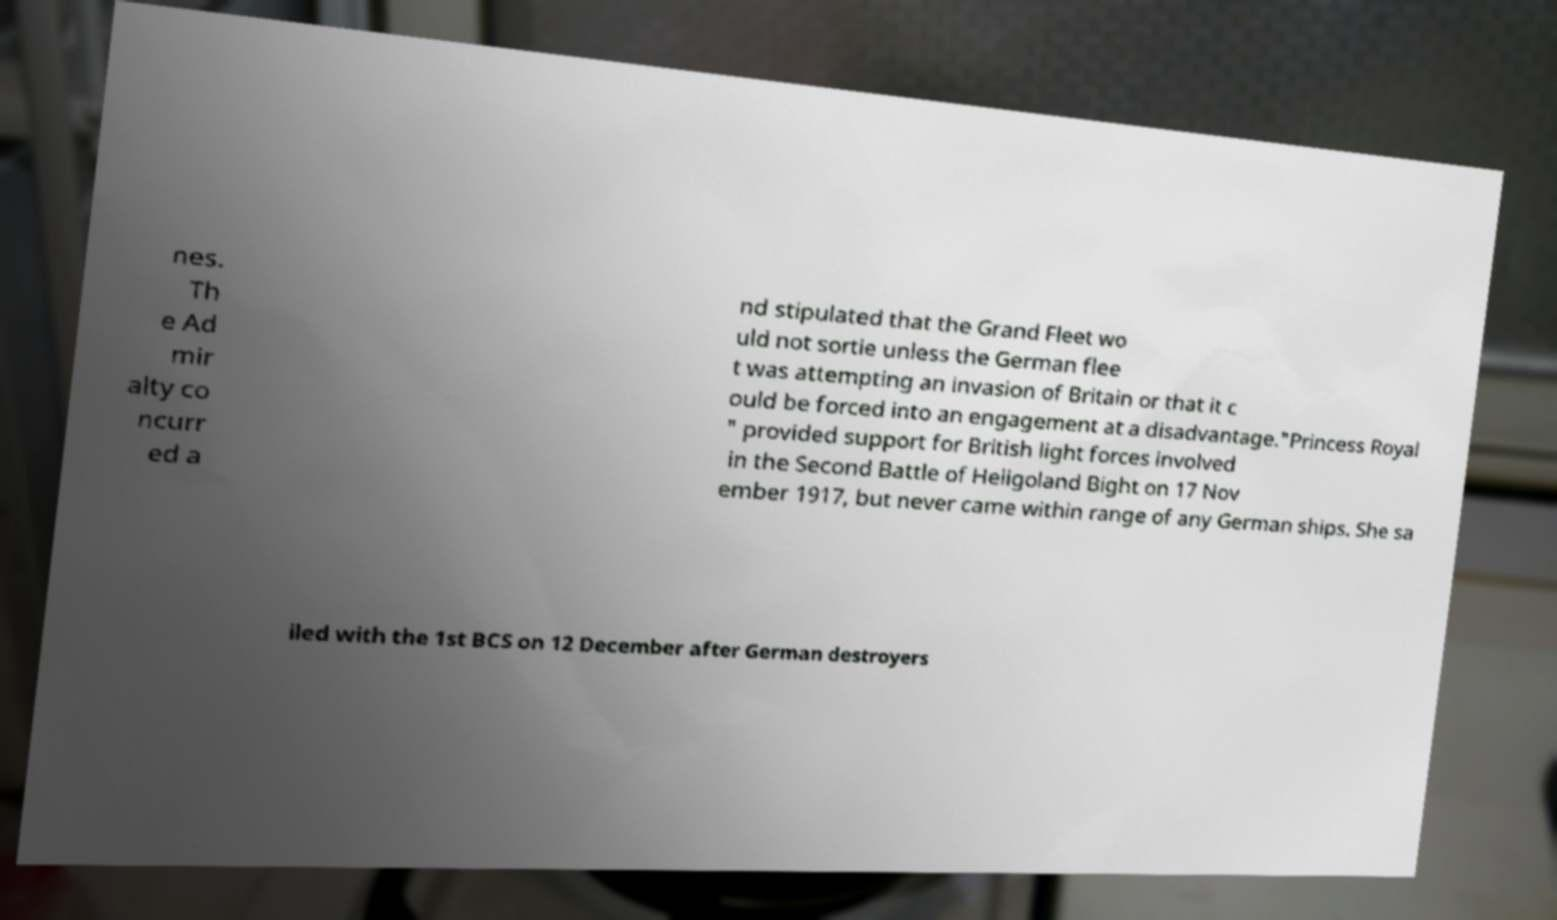There's text embedded in this image that I need extracted. Can you transcribe it verbatim? nes. Th e Ad mir alty co ncurr ed a nd stipulated that the Grand Fleet wo uld not sortie unless the German flee t was attempting an invasion of Britain or that it c ould be forced into an engagement at a disadvantage."Princess Royal " provided support for British light forces involved in the Second Battle of Heligoland Bight on 17 Nov ember 1917, but never came within range of any German ships. She sa iled with the 1st BCS on 12 December after German destroyers 